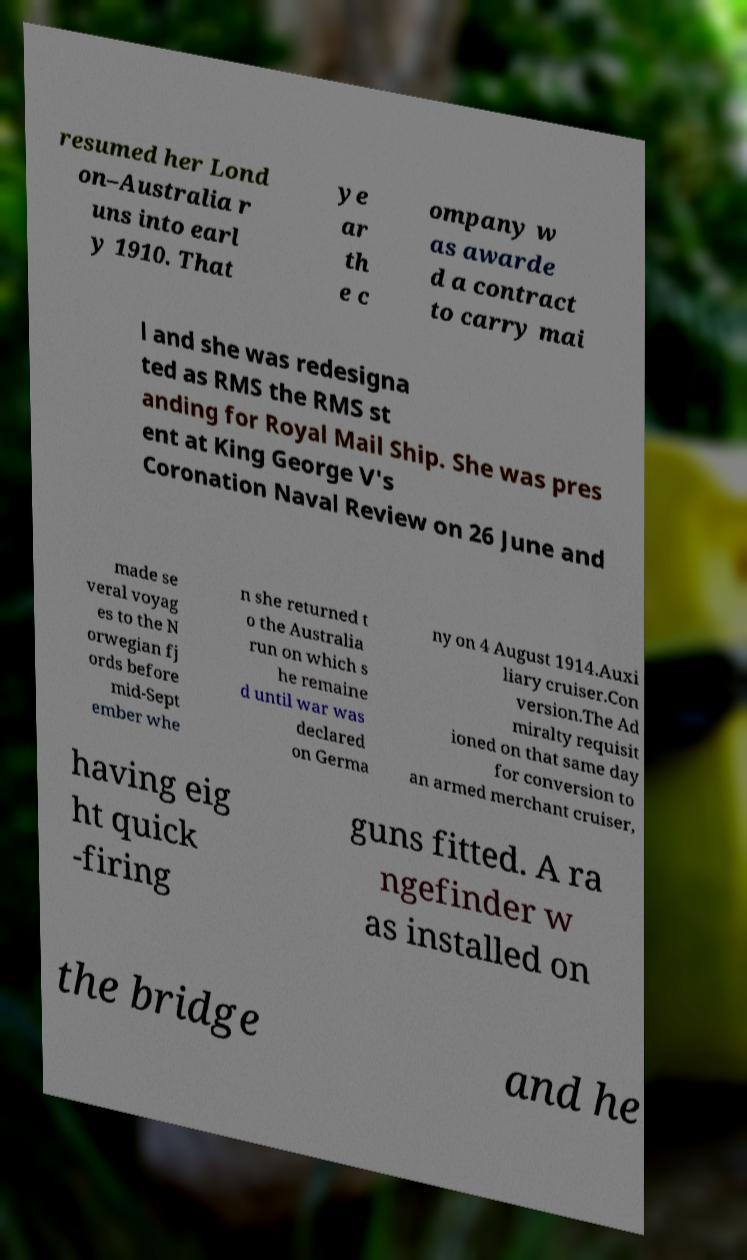I need the written content from this picture converted into text. Can you do that? resumed her Lond on–Australia r uns into earl y 1910. That ye ar th e c ompany w as awarde d a contract to carry mai l and she was redesigna ted as RMS the RMS st anding for Royal Mail Ship. She was pres ent at King George V's Coronation Naval Review on 26 June and made se veral voyag es to the N orwegian fj ords before mid-Sept ember whe n she returned t o the Australia run on which s he remaine d until war was declared on Germa ny on 4 August 1914.Auxi liary cruiser.Con version.The Ad miralty requisit ioned on that same day for conversion to an armed merchant cruiser, having eig ht quick -firing guns fitted. A ra ngefinder w as installed on the bridge and he 